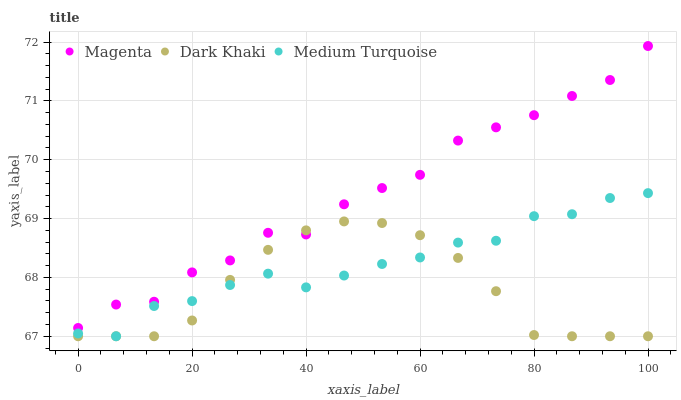Does Dark Khaki have the minimum area under the curve?
Answer yes or no. Yes. Does Magenta have the maximum area under the curve?
Answer yes or no. Yes. Does Medium Turquoise have the minimum area under the curve?
Answer yes or no. No. Does Medium Turquoise have the maximum area under the curve?
Answer yes or no. No. Is Dark Khaki the smoothest?
Answer yes or no. Yes. Is Magenta the roughest?
Answer yes or no. Yes. Is Medium Turquoise the smoothest?
Answer yes or no. No. Is Medium Turquoise the roughest?
Answer yes or no. No. Does Dark Khaki have the lowest value?
Answer yes or no. Yes. Does Magenta have the lowest value?
Answer yes or no. No. Does Magenta have the highest value?
Answer yes or no. Yes. Does Medium Turquoise have the highest value?
Answer yes or no. No. Is Medium Turquoise less than Magenta?
Answer yes or no. Yes. Is Magenta greater than Medium Turquoise?
Answer yes or no. Yes. Does Dark Khaki intersect Magenta?
Answer yes or no. Yes. Is Dark Khaki less than Magenta?
Answer yes or no. No. Is Dark Khaki greater than Magenta?
Answer yes or no. No. Does Medium Turquoise intersect Magenta?
Answer yes or no. No. 